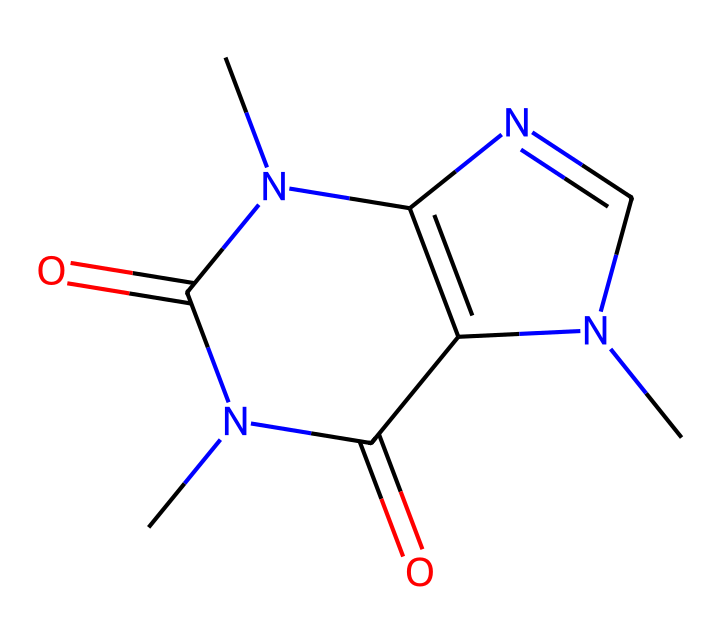What is the total number of carbon atoms in this chemical? The chemical structure represents caffeine, which can be analyzed to count its carbon atoms. By inspecting the SMILES representation, which indicates each atom, we identify 8 carbon atoms in total.
Answer: 8 How many nitrogen atoms are present in the structure? In the provided SMILES, there are nitrogen atoms (`N`) indicated. By counting, we observe 4 nitrogen atoms are present in the caffeine structure.
Answer: 4 What type of compound is caffeine classified as? Caffeine is classified as a non-electrolyte due to its molecular structure, allowing it to dissolve in water without dissociating into ions.
Answer: non-electrolyte What is the molecular weight of caffeine? The molecular weight can be calculated using the atomic weights of carbon (12.01), hydrogen (1.008), nitrogen (14.01), and oxygen (16.00), accumulated from the structure's composition: C8H10N4O2 results in approximately 194.19 g/mol.
Answer: 194.19 g/mol Which two functional groups can be observed in caffeine? The caffeine structure reveals the presence of amine groups (due to nitrogen atoms) and carbonyl groups (due to carbon-oxygen double bonds), both integral to its functionality.
Answer: amine and carbonyl How does caffeine affect neurological function? Caffeine acts as a stimulant on the central nervous system due to its structural similarity to adenosine, enabling it to block its receptors and promote alertness.
Answer: stimulation What structural feature contributes to caffeine's solubility? The polar functional groups, particularly the nitrogen and oxygen atoms, contribute to the solubility of caffeine in polar solvents like water.
Answer: polar groups 